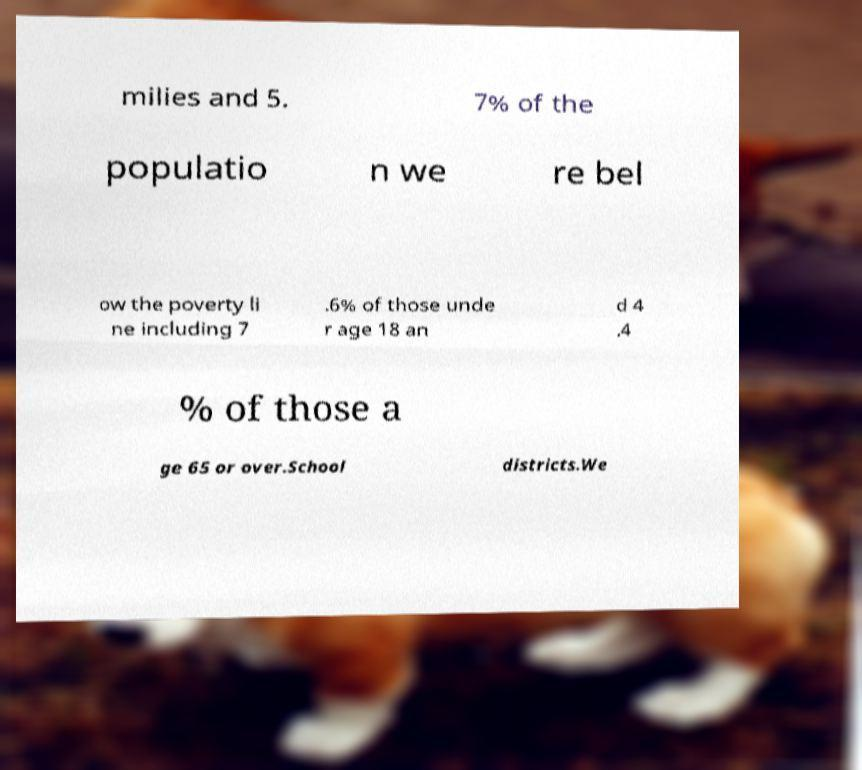There's text embedded in this image that I need extracted. Can you transcribe it verbatim? milies and 5. 7% of the populatio n we re bel ow the poverty li ne including 7 .6% of those unde r age 18 an d 4 .4 % of those a ge 65 or over.School districts.We 